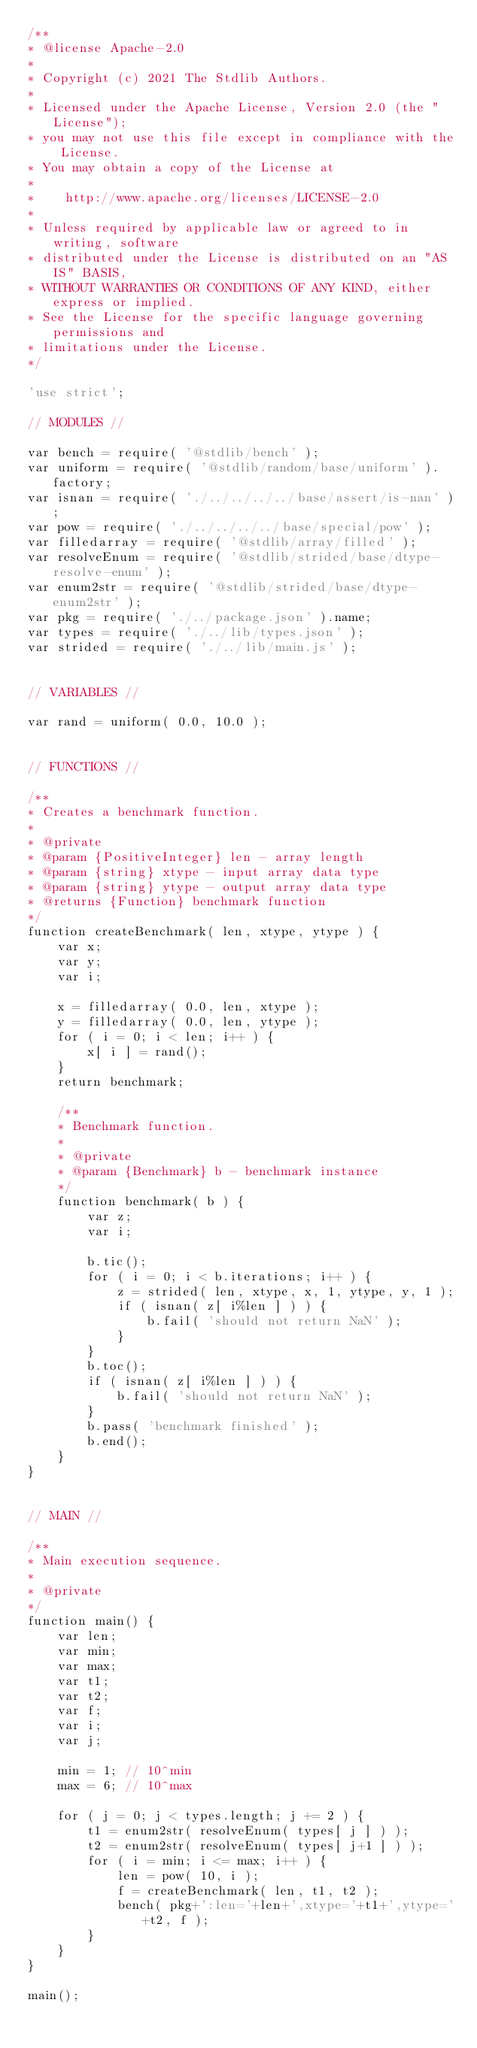<code> <loc_0><loc_0><loc_500><loc_500><_JavaScript_>/**
* @license Apache-2.0
*
* Copyright (c) 2021 The Stdlib Authors.
*
* Licensed under the Apache License, Version 2.0 (the "License");
* you may not use this file except in compliance with the License.
* You may obtain a copy of the License at
*
*    http://www.apache.org/licenses/LICENSE-2.0
*
* Unless required by applicable law or agreed to in writing, software
* distributed under the License is distributed on an "AS IS" BASIS,
* WITHOUT WARRANTIES OR CONDITIONS OF ANY KIND, either express or implied.
* See the License for the specific language governing permissions and
* limitations under the License.
*/

'use strict';

// MODULES //

var bench = require( '@stdlib/bench' );
var uniform = require( '@stdlib/random/base/uniform' ).factory;
var isnan = require( './../../../../base/assert/is-nan' );
var pow = require( './../../../../base/special/pow' );
var filledarray = require( '@stdlib/array/filled' );
var resolveEnum = require( '@stdlib/strided/base/dtype-resolve-enum' );
var enum2str = require( '@stdlib/strided/base/dtype-enum2str' );
var pkg = require( './../package.json' ).name;
var types = require( './../lib/types.json' );
var strided = require( './../lib/main.js' );


// VARIABLES //

var rand = uniform( 0.0, 10.0 );


// FUNCTIONS //

/**
* Creates a benchmark function.
*
* @private
* @param {PositiveInteger} len - array length
* @param {string} xtype - input array data type
* @param {string} ytype - output array data type
* @returns {Function} benchmark function
*/
function createBenchmark( len, xtype, ytype ) {
	var x;
	var y;
	var i;

	x = filledarray( 0.0, len, xtype );
	y = filledarray( 0.0, len, ytype );
	for ( i = 0; i < len; i++ ) {
		x[ i ] = rand();
	}
	return benchmark;

	/**
	* Benchmark function.
	*
	* @private
	* @param {Benchmark} b - benchmark instance
	*/
	function benchmark( b ) {
		var z;
		var i;

		b.tic();
		for ( i = 0; i < b.iterations; i++ ) {
			z = strided( len, xtype, x, 1, ytype, y, 1 );
			if ( isnan( z[ i%len ] ) ) {
				b.fail( 'should not return NaN' );
			}
		}
		b.toc();
		if ( isnan( z[ i%len ] ) ) {
			b.fail( 'should not return NaN' );
		}
		b.pass( 'benchmark finished' );
		b.end();
	}
}


// MAIN //

/**
* Main execution sequence.
*
* @private
*/
function main() {
	var len;
	var min;
	var max;
	var t1;
	var t2;
	var f;
	var i;
	var j;

	min = 1; // 10^min
	max = 6; // 10^max

	for ( j = 0; j < types.length; j += 2 ) {
		t1 = enum2str( resolveEnum( types[ j ] ) );
		t2 = enum2str( resolveEnum( types[ j+1 ] ) );
		for ( i = min; i <= max; i++ ) {
			len = pow( 10, i );
			f = createBenchmark( len, t1, t2 );
			bench( pkg+':len='+len+',xtype='+t1+',ytype='+t2, f );
		}
	}
}

main();
</code> 